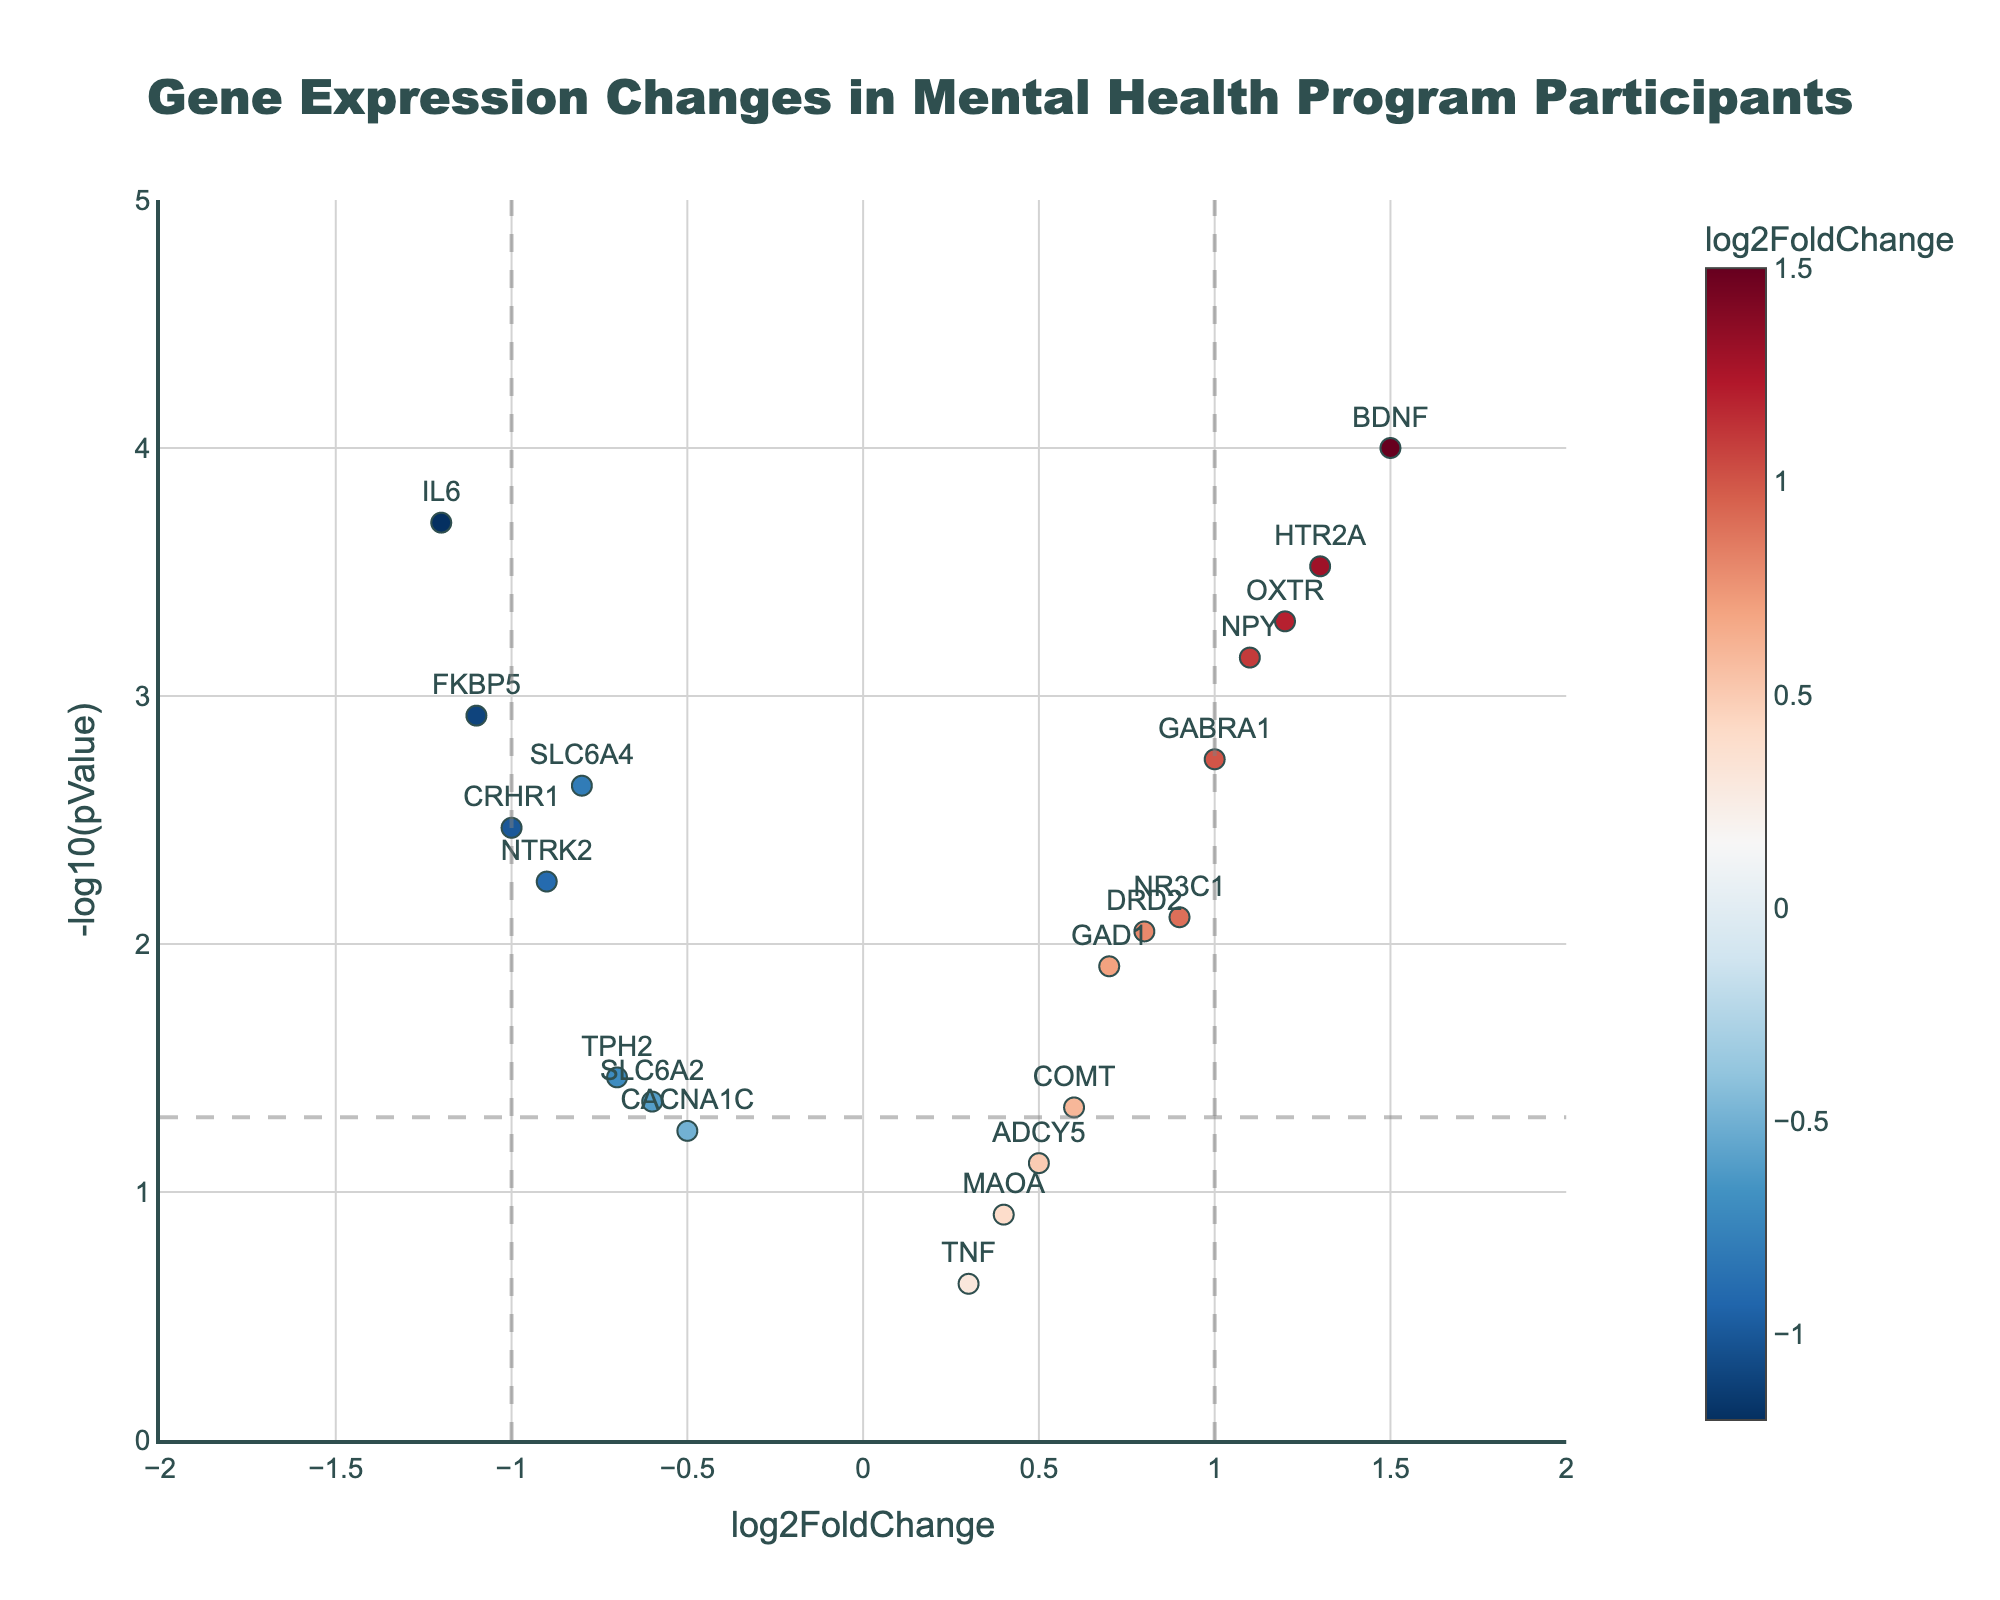What is the title of the plot? The title is located at the top of the figure and it provides a brief description of what the plot represents. In this case, it states "Gene Expression Changes in Mental Health Program Participants".
Answer: Gene Expression Changes in Mental Health Program Participants How many genes have a log2FoldChange greater than 1? To determine this, observe the x-axis labeled "log2FoldChange" and count the number of data points (genes) positioned to the right of the vertical line at x = 1.
Answer: 4 Which gene has the highest -log10(pValue)? Locate the highest data point along the y-axis labeled "-log10(pValue)". Hovering over the point reveals the Gene, log2FoldChange, and p-value.
Answer: BDNF How many genes have a statistically significant p-value (p < 0.05)? To find this, look for data points above the horizontal dashed line at y = -log10(0.05). Count all such points.
Answer: 14 Which genes have a log2FoldChange less than -1? Look to the left of the vertical dashed line at x = -1 on the x-axis and identify the genes corresponding to these data points.
Answer: FKBP5, IL6 What is the log2FoldChange of the gene TPH2? Locate the data point labeled "TPH2" and read its position along the x-axis.
Answer: -0.7 Which gene has the smallest log2FoldChange among the significantly changed genes (p < 0.05)? Among the points above the horizontal dashed line at y = -log10(0.05), find the point furthest to the left on the x-axis.
Answer: FKBP5 How many genes have both a log2FoldChange between -0.5 and 0.5 and a non-significant p-value (p >= 0.05)? Focus on the data points within the range -0.5 < log2FoldChange < 0.5 along the x-axis and below the horizontal dashed line at y = -log10(0.05). Count these points.
Answer: 3 Which gene shows a notably high log2FoldChange and low p-value, indicating a strong upregulation? Identify the gene(s) to the far right on the x-axis (large log2FoldChange) and high on the y-axis (low p-value).
Answer: BDNF 